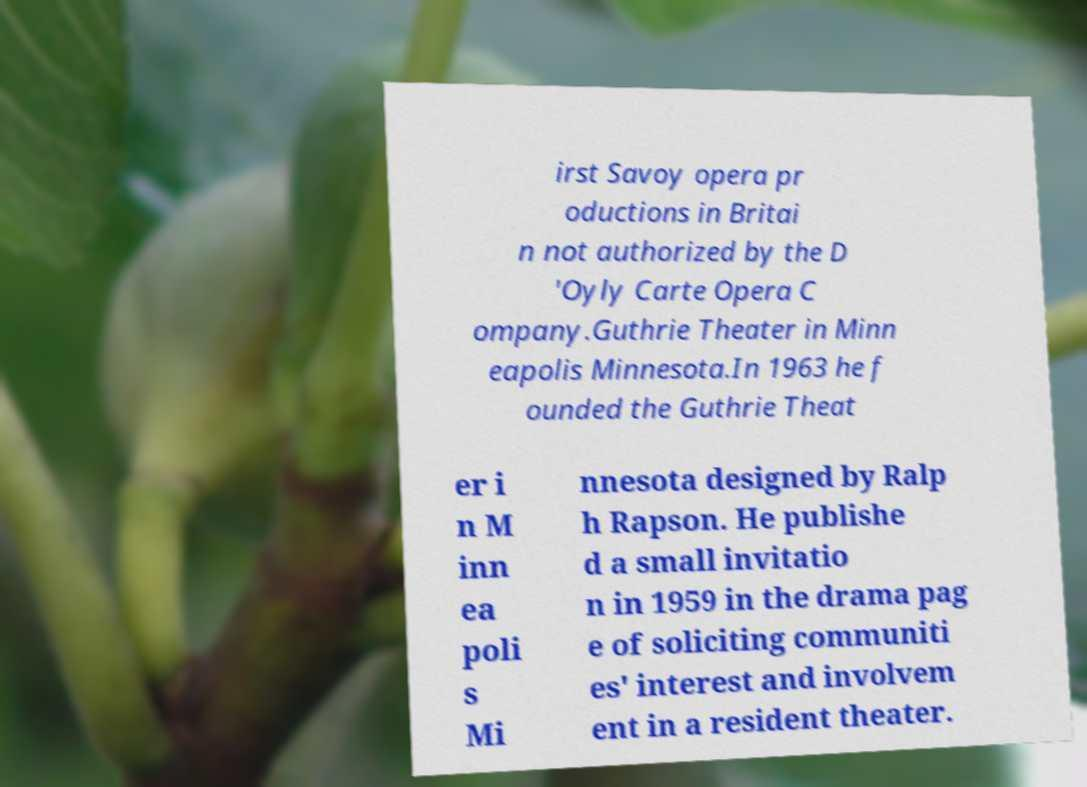For documentation purposes, I need the text within this image transcribed. Could you provide that? irst Savoy opera pr oductions in Britai n not authorized by the D 'Oyly Carte Opera C ompany.Guthrie Theater in Minn eapolis Minnesota.In 1963 he f ounded the Guthrie Theat er i n M inn ea poli s Mi nnesota designed by Ralp h Rapson. He publishe d a small invitatio n in 1959 in the drama pag e of soliciting communiti es' interest and involvem ent in a resident theater. 